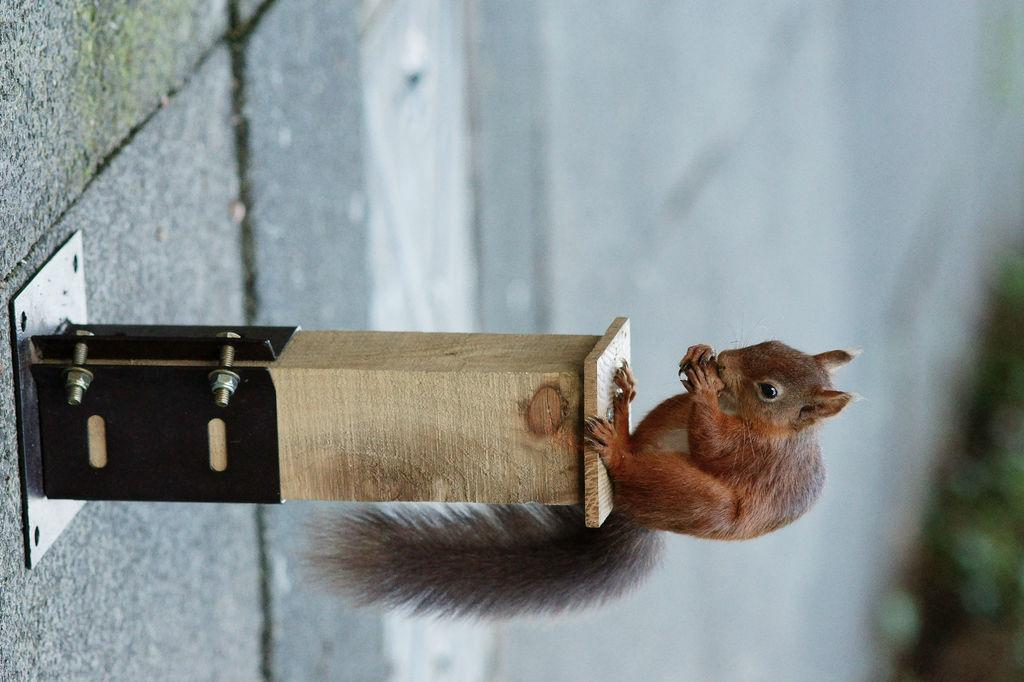What animal is present in the image? There is a squirrel in the image. What is the squirrel standing on? The squirrel is on a wooden stand. What is the squirrel holding in its hands? The squirrel is holding something in its hands. Can you describe the background of the image? The background of the image is blurry. What type of clouds can be seen in the image? There are no clouds visible in the image, as the background is blurry and does not show any clouds. 